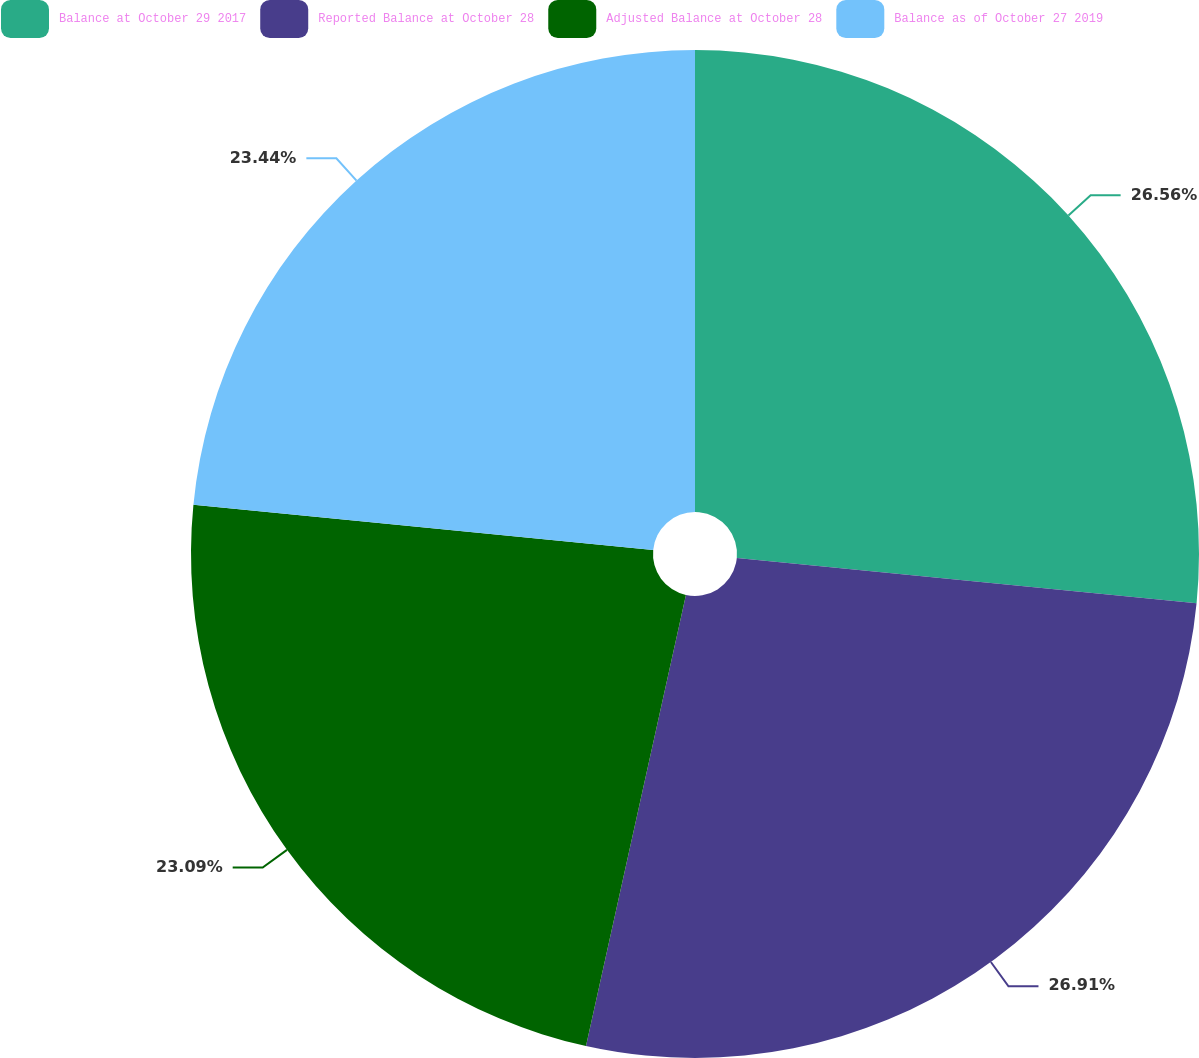<chart> <loc_0><loc_0><loc_500><loc_500><pie_chart><fcel>Balance at October 29 2017<fcel>Reported Balance at October 28<fcel>Adjusted Balance at October 28<fcel>Balance as of October 27 2019<nl><fcel>26.56%<fcel>26.91%<fcel>23.09%<fcel>23.44%<nl></chart> 